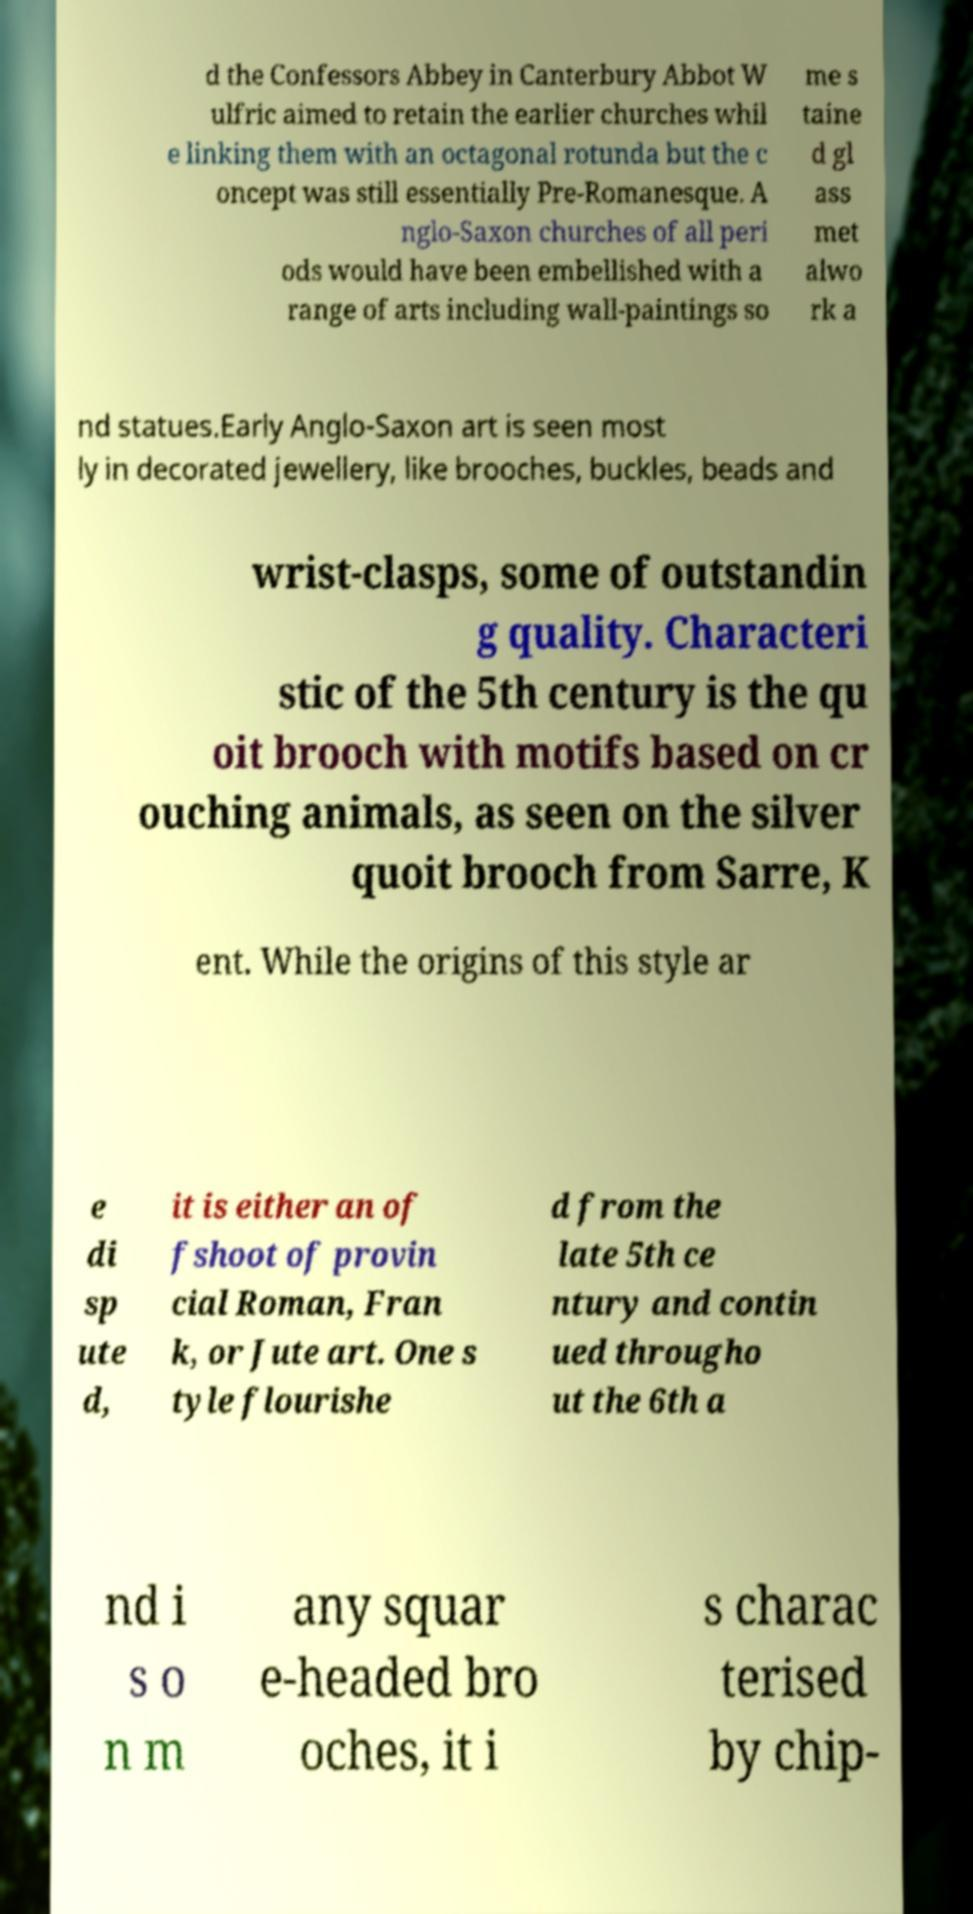I need the written content from this picture converted into text. Can you do that? d the Confessors Abbey in Canterbury Abbot W ulfric aimed to retain the earlier churches whil e linking them with an octagonal rotunda but the c oncept was still essentially Pre-Romanesque. A nglo-Saxon churches of all peri ods would have been embellished with a range of arts including wall-paintings so me s taine d gl ass met alwo rk a nd statues.Early Anglo-Saxon art is seen most ly in decorated jewellery, like brooches, buckles, beads and wrist-clasps, some of outstandin g quality. Characteri stic of the 5th century is the qu oit brooch with motifs based on cr ouching animals, as seen on the silver quoit brooch from Sarre, K ent. While the origins of this style ar e di sp ute d, it is either an of fshoot of provin cial Roman, Fran k, or Jute art. One s tyle flourishe d from the late 5th ce ntury and contin ued througho ut the 6th a nd i s o n m any squar e-headed bro oches, it i s charac terised by chip- 